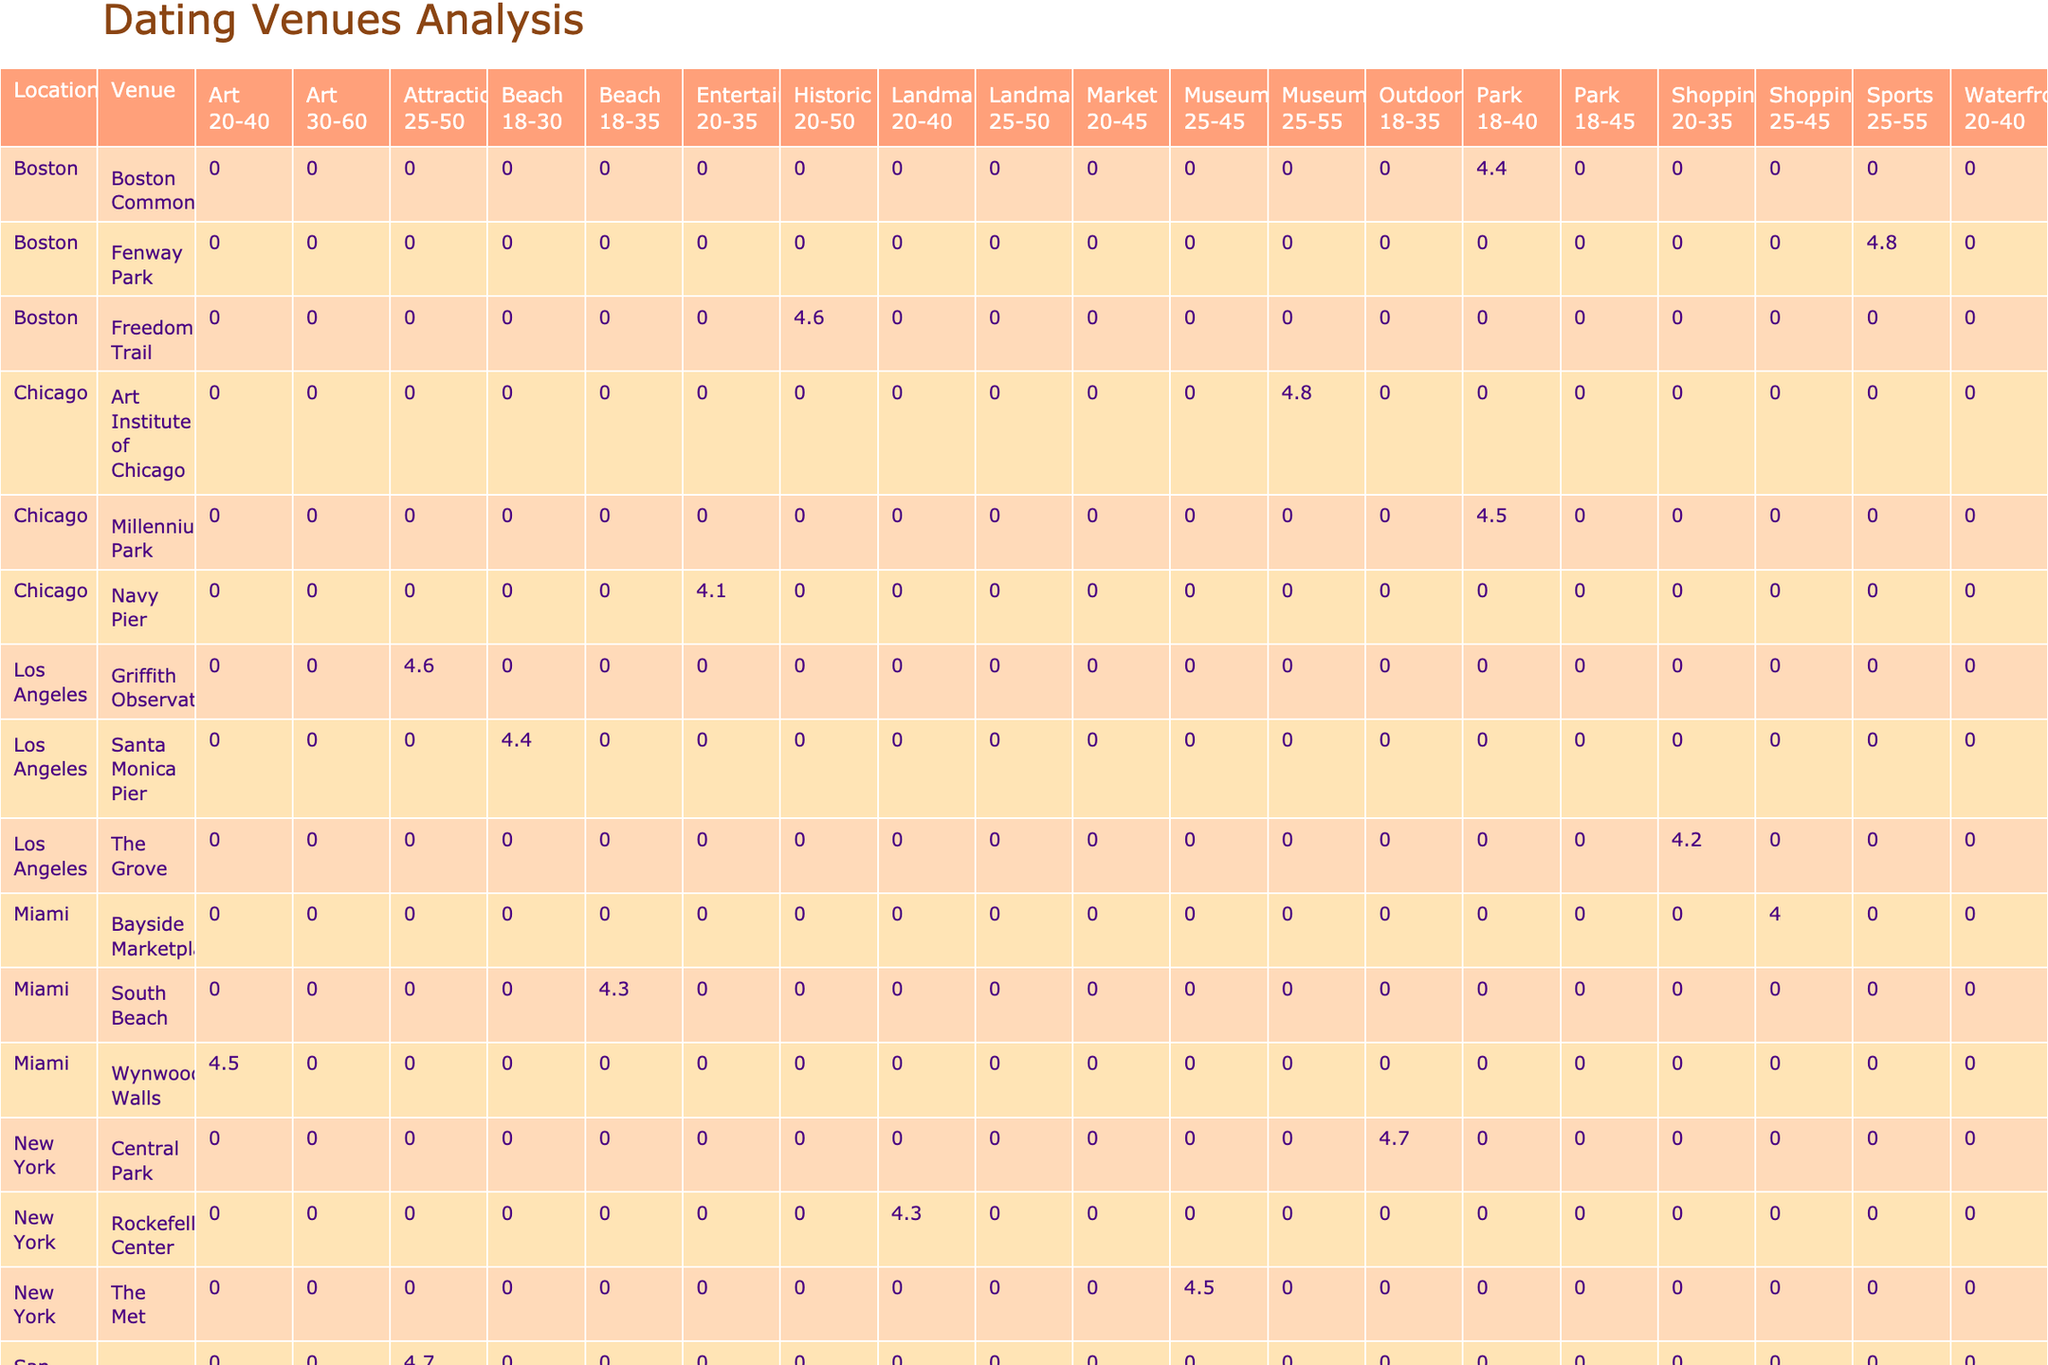What is the venue with the highest average rating in New York? Central Park has the highest average rating of 4.7 among New York venues, as indicated in the table. I found this by checking each venue's rating listed under the New York location.
Answer: Central Park Which age group enjoys Millennium Park in Chicago the most? The table provides the average rating for Millennium Park under the "Any" age group, which is 4.5. This means it is suitable for all age groups, but it doesn't specify a particular age group that enjoys it the most.
Answer: Any age group What is the average rating of venues in Los Angeles that are classified as attractions? There are two attraction venues: Griffith Observatory (4.6 rating) and Santa Monica Pier (4.4 rating). Adding these ratings (4.6 + 4.4 = 9) and dividing by 2 gives an average of 4.5.
Answer: 4.5 Is the average rating for shopping venues across all locations higher than 4.5? The ratings for shopping venues are: The Grove (4.2 in Los Angeles), Bayside Marketplace (4.0 in Miami), and no shopping venues in other locations. Adding these (4.2 + 4.0 = 8.2) and dividing by 2, the average is 4.1, which is less than 4.5.
Answer: No Which location has more venues with average ratings higher than 4.5? I checked each location and counted the venues with average ratings above 4.5: New York has 3 (Central Park, The Met), Chicago has 2 (Art Institute of Chicago, Millennium Park), and San Francisco has 2 (Alcatraz Island, Golden Gate Park). Since New York has the most, it has more venues than the others.
Answer: New York What is the average rating of outdoor venues across all locations? The outdoor venues are Central Park (4.7), Millennium Park (4.5), and Golden Gate Park (4.6). Adding the ratings (4.7 + 4.5 + 4.6 = 13.8) and dividing by 3 gives an average of 4.6.
Answer: 4.6 Do any venues in Boston have an average rating less than 4.4? Checking the Boston venues, Fenway Park has an average rating of 4.8, Freedom Trail has 4.6, and Boston Common has 4.4. None of the Boston venues fall below an average rating of 4.4.
Answer: No Which venue has the lowest average rating in Seattle? In Seattle, the lowest average rating is for Space Needle, which has a 4.3 rating, according to the table.
Answer: Space Needle How many reviews does the highest-rated venue in Miami have? The highest average rating in Miami is for Wynwood Walls with a rating of 4.5, which has 1800 reviews according to the table.
Answer: 1800 reviews 